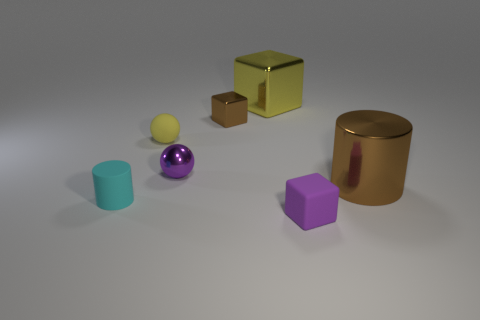Do these objects suggest any particular use or function? These objects don't seem to have any overt function; they are likely used for visual or educational purposes, perhaps in a teaching setting to discuss shapes, colors, or materials. Their simplistic design and varied colors make them ideal for exercises in identification or sorting. 